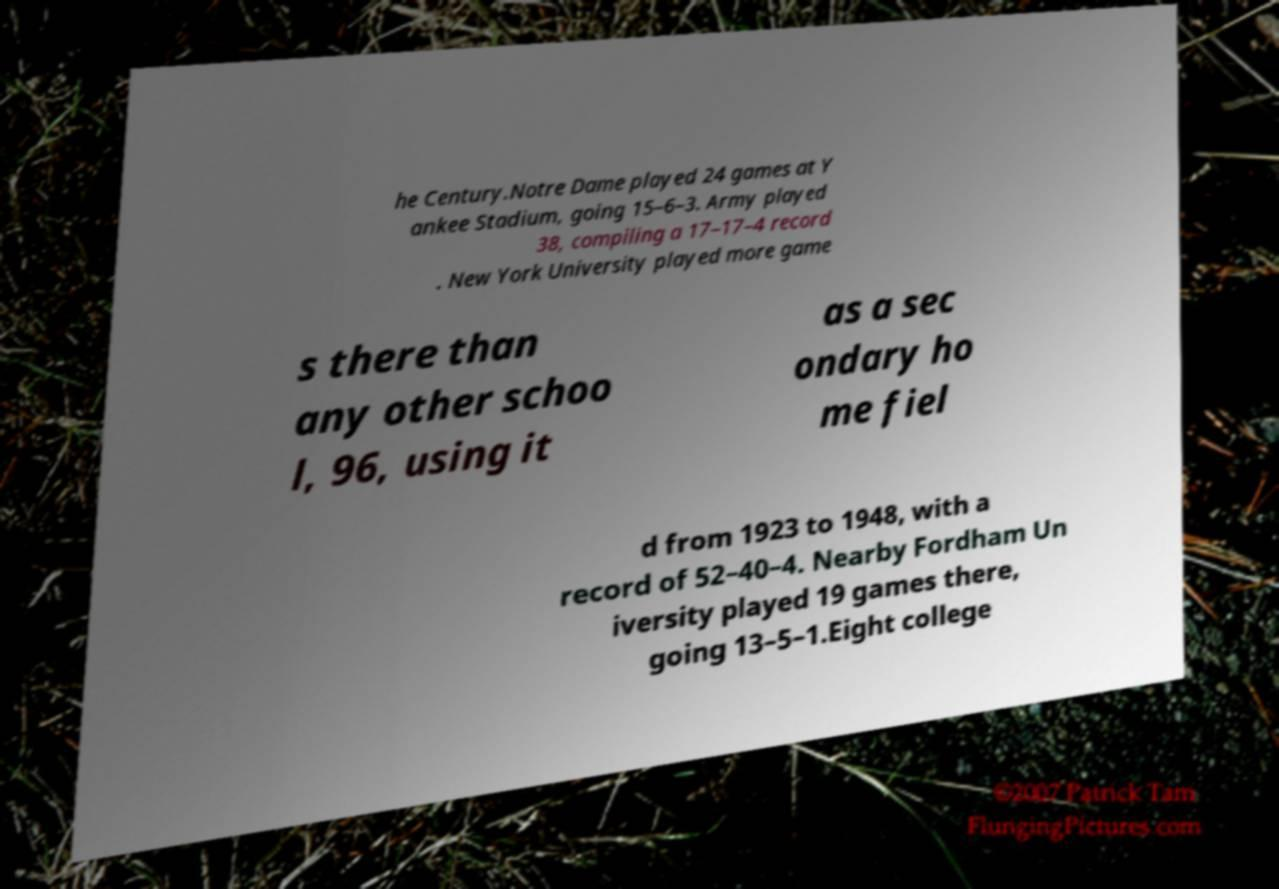Could you extract and type out the text from this image? he Century.Notre Dame played 24 games at Y ankee Stadium, going 15–6–3. Army played 38, compiling a 17–17–4 record . New York University played more game s there than any other schoo l, 96, using it as a sec ondary ho me fiel d from 1923 to 1948, with a record of 52–40–4. Nearby Fordham Un iversity played 19 games there, going 13–5–1.Eight college 